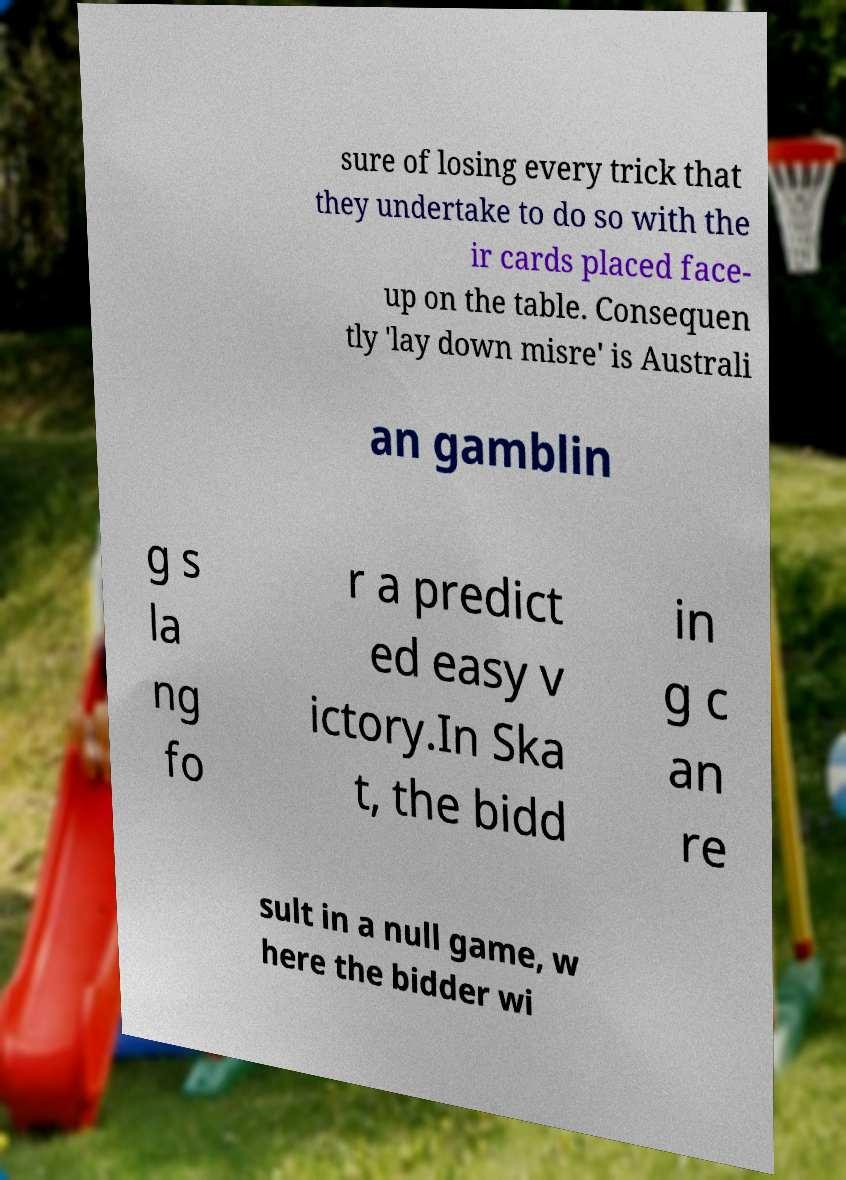Could you extract and type out the text from this image? sure of losing every trick that they undertake to do so with the ir cards placed face- up on the table. Consequen tly 'lay down misre' is Australi an gamblin g s la ng fo r a predict ed easy v ictory.In Ska t, the bidd in g c an re sult in a null game, w here the bidder wi 